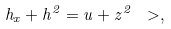Convert formula to latex. <formula><loc_0><loc_0><loc_500><loc_500>h _ { x } + h ^ { 2 } = u + z ^ { 2 } \ > ,</formula> 